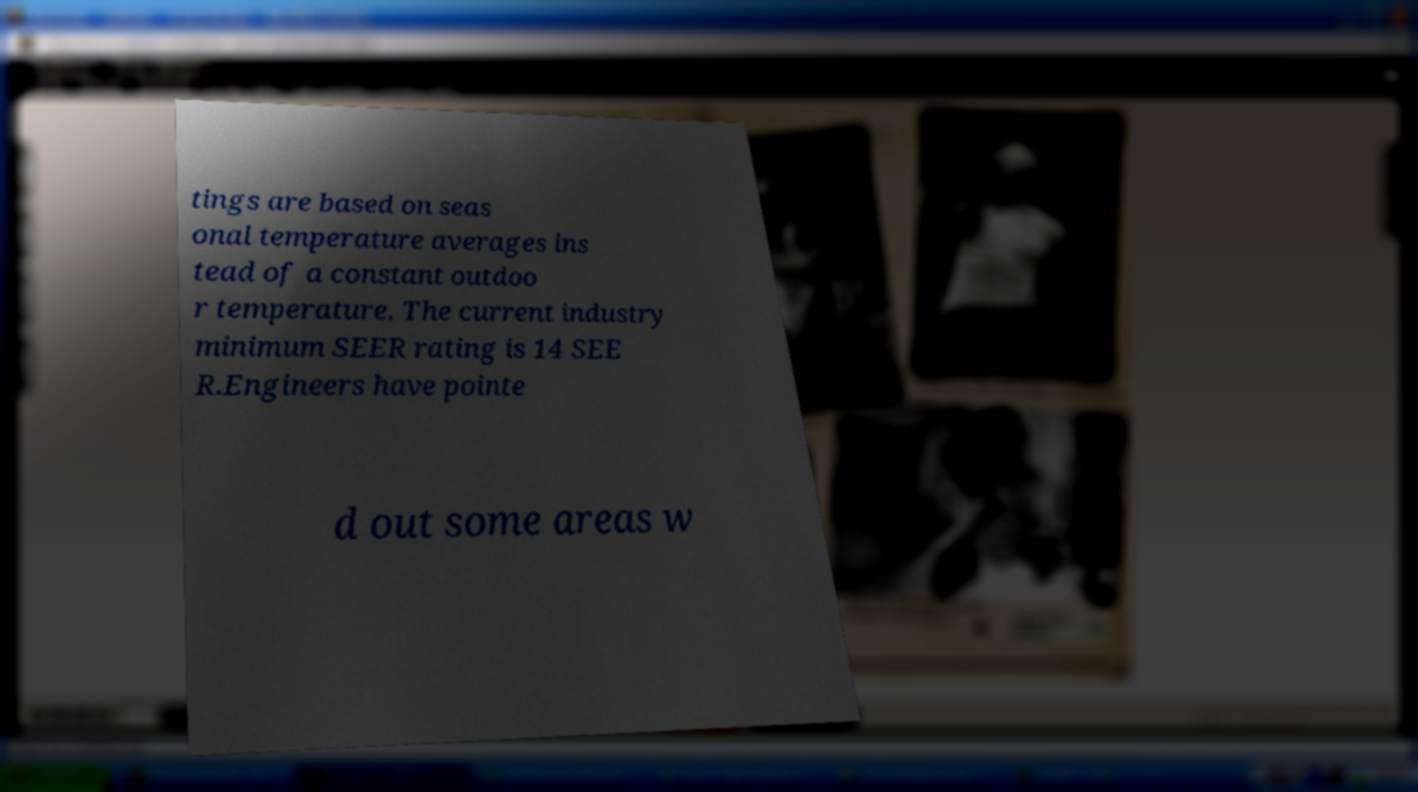Can you read and provide the text displayed in the image?This photo seems to have some interesting text. Can you extract and type it out for me? tings are based on seas onal temperature averages ins tead of a constant outdoo r temperature. The current industry minimum SEER rating is 14 SEE R.Engineers have pointe d out some areas w 